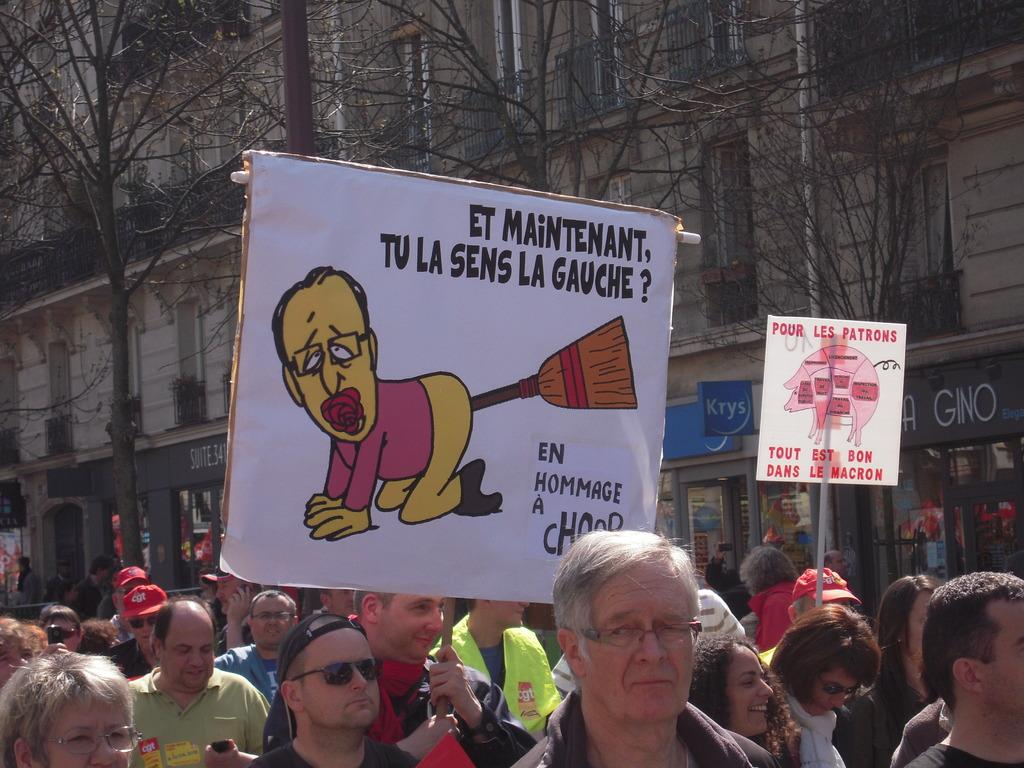How many people are present in the image? There are many people in the image. What is the man in the middle of the image holding? The man is holding a placard in the middle of the image. What can be seen in the background of the image? There are trees, buildings, and boards visible in the background of the image. What type of wood is the frame of the image made of? There is no frame present in the image, as it is a photograph or digital representation. 